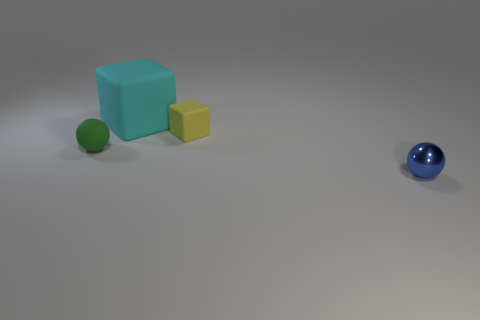Add 2 big metallic cylinders. How many objects exist? 6 Add 2 big purple metallic objects. How many big purple metallic objects exist? 2 Subtract 0 purple spheres. How many objects are left? 4 Subtract all blue spheres. Subtract all shiny things. How many objects are left? 2 Add 4 yellow cubes. How many yellow cubes are left? 5 